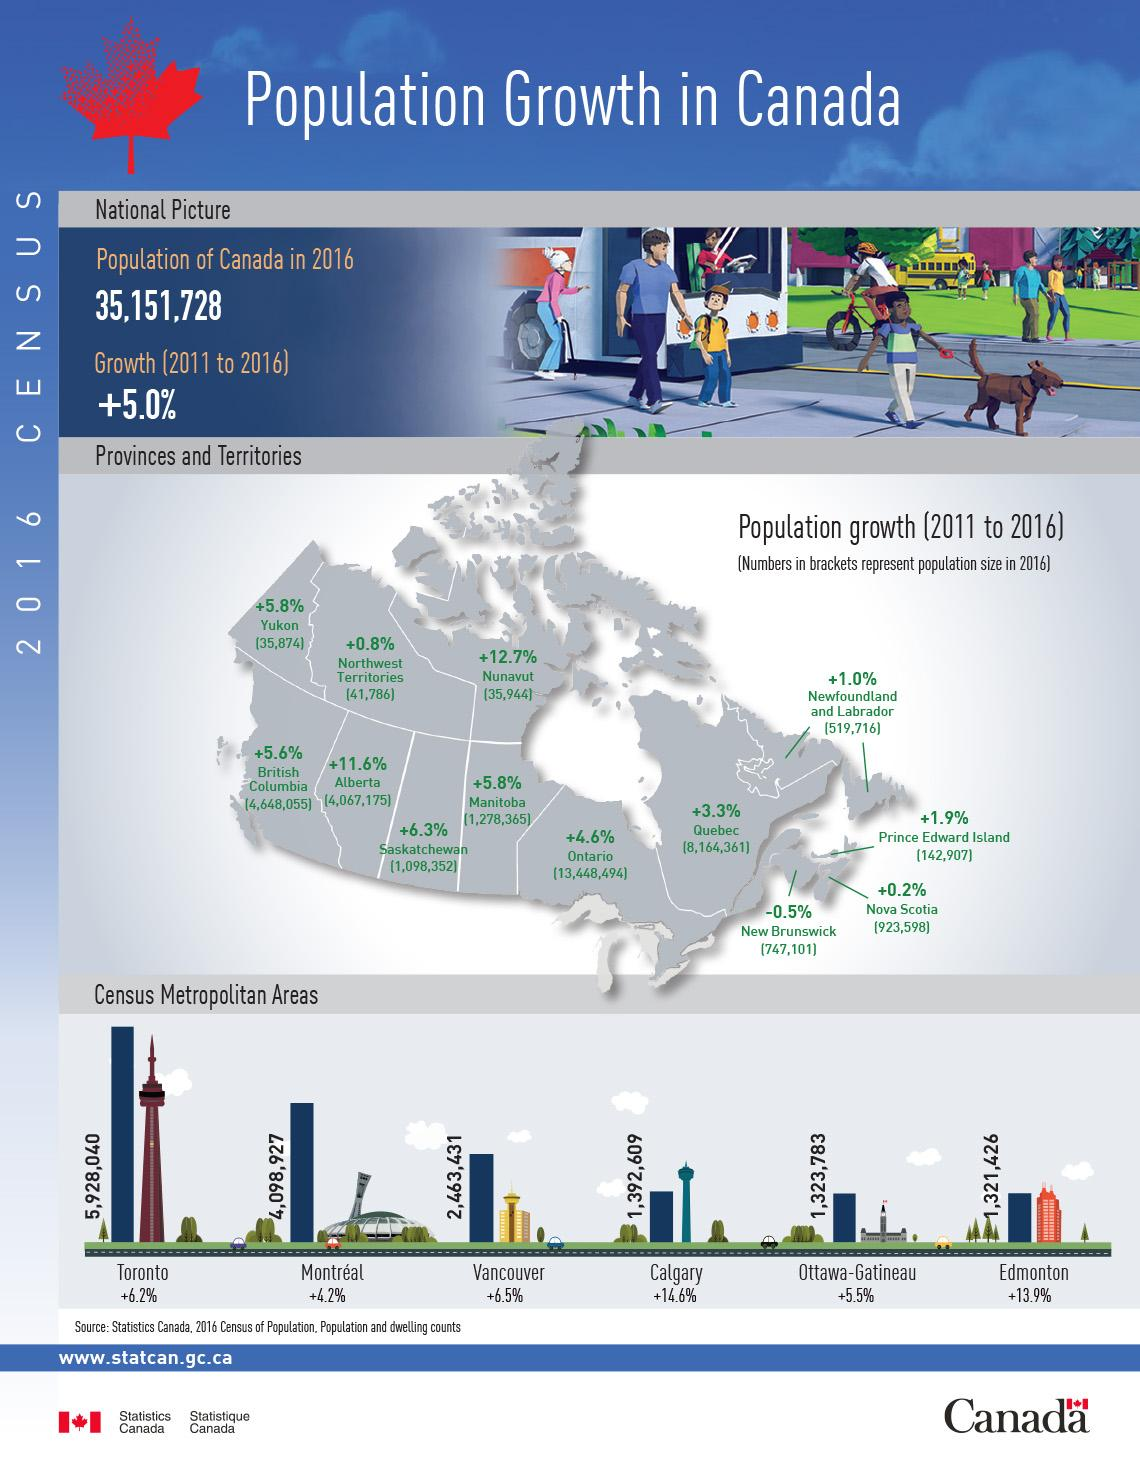Indicate a few pertinent items in this graphic. In 2016, the population of Manitoba was 1,278,365. In 2016, the population of Alberta was 4067175. The metropolitan area with the largest population is Toronto. In 2016, the population of Quebec was 816,436. Six territories have a population growth rate that exceeds the national average. 